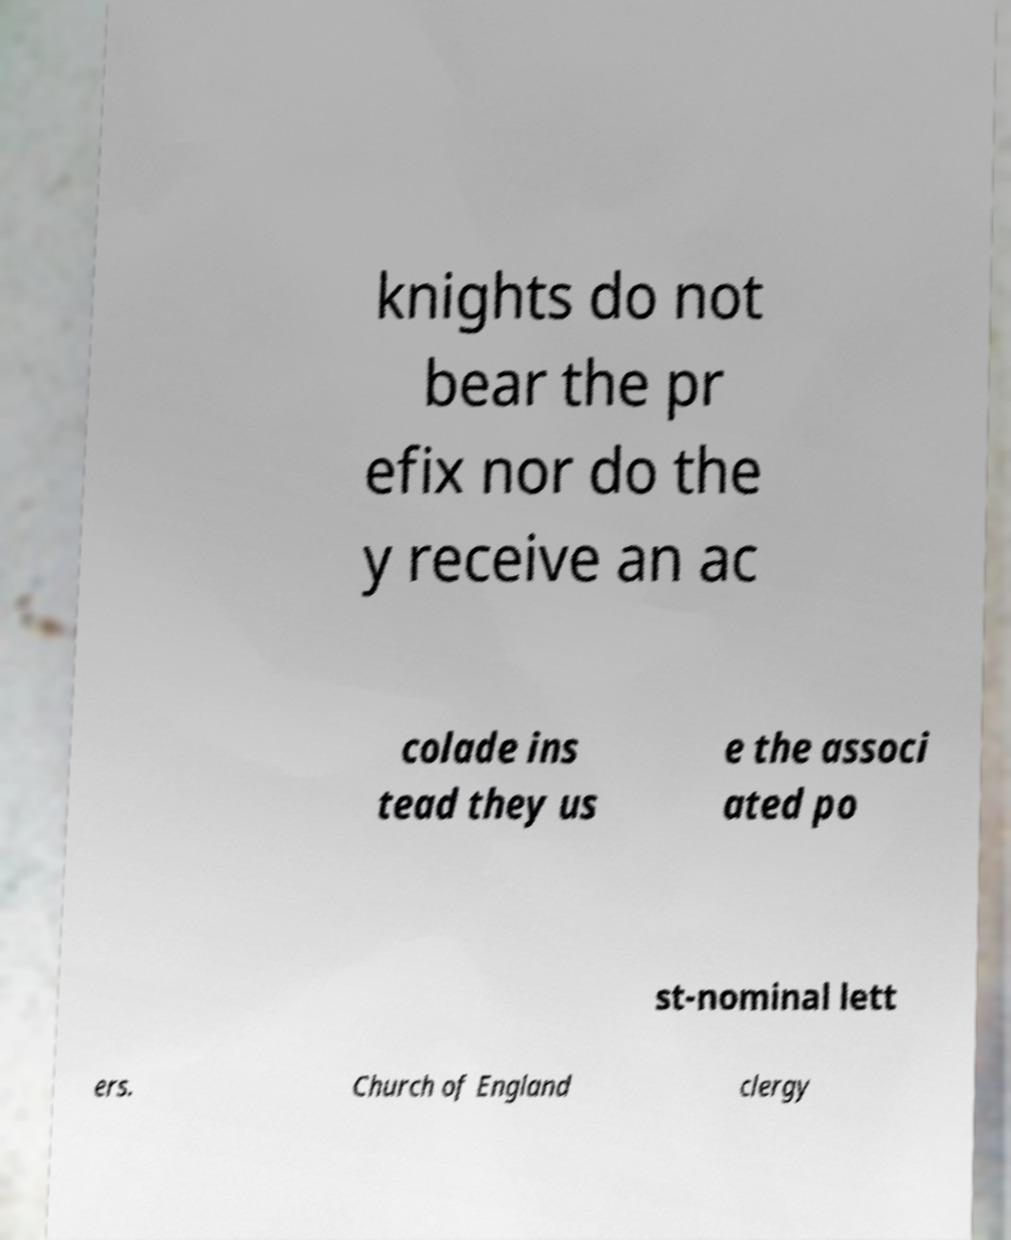Please read and relay the text visible in this image. What does it say? knights do not bear the pr efix nor do the y receive an ac colade ins tead they us e the associ ated po st-nominal lett ers. Church of England clergy 